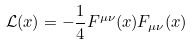<formula> <loc_0><loc_0><loc_500><loc_500>\mathcal { L } ( x ) = - \frac { 1 } { 4 } F ^ { \mu \nu } ( x ) F _ { \mu \nu } ( x )</formula> 